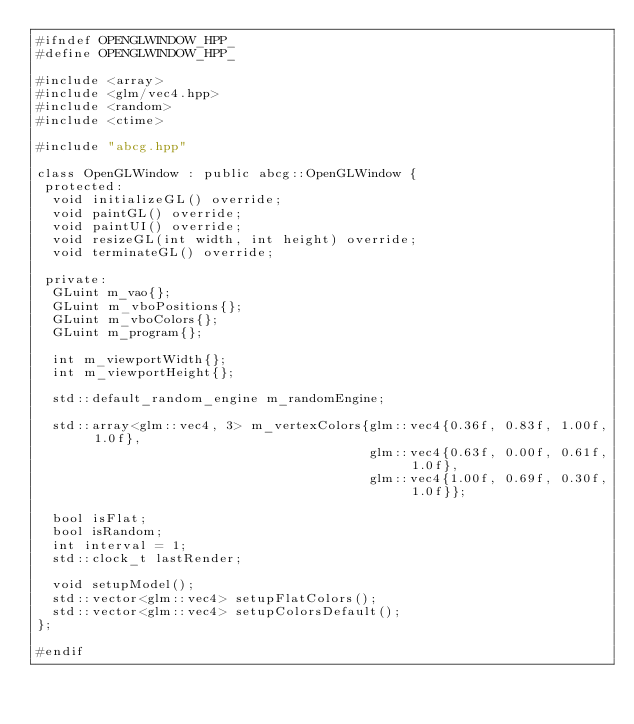Convert code to text. <code><loc_0><loc_0><loc_500><loc_500><_C++_>#ifndef OPENGLWINDOW_HPP_
#define OPENGLWINDOW_HPP_

#include <array>
#include <glm/vec4.hpp>
#include <random>
#include <ctime>

#include "abcg.hpp"

class OpenGLWindow : public abcg::OpenGLWindow {
 protected:
  void initializeGL() override;
  void paintGL() override;
  void paintUI() override;
  void resizeGL(int width, int height) override;
  void terminateGL() override;

 private:
  GLuint m_vao{};
  GLuint m_vboPositions{};
  GLuint m_vboColors{};
  GLuint m_program{};

  int m_viewportWidth{};
  int m_viewportHeight{};

  std::default_random_engine m_randomEngine;

  std::array<glm::vec4, 3> m_vertexColors{glm::vec4{0.36f, 0.83f, 1.00f, 1.0f},
                                          glm::vec4{0.63f, 0.00f, 0.61f, 1.0f},
                                          glm::vec4{1.00f, 0.69f, 0.30f, 1.0f}};

  bool isFlat;
  bool isRandom;
  int interval = 1;
  std::clock_t lastRender;

  void setupModel();
  std::vector<glm::vec4> setupFlatColors();
  std::vector<glm::vec4> setupColorsDefault();
};

#endif</code> 